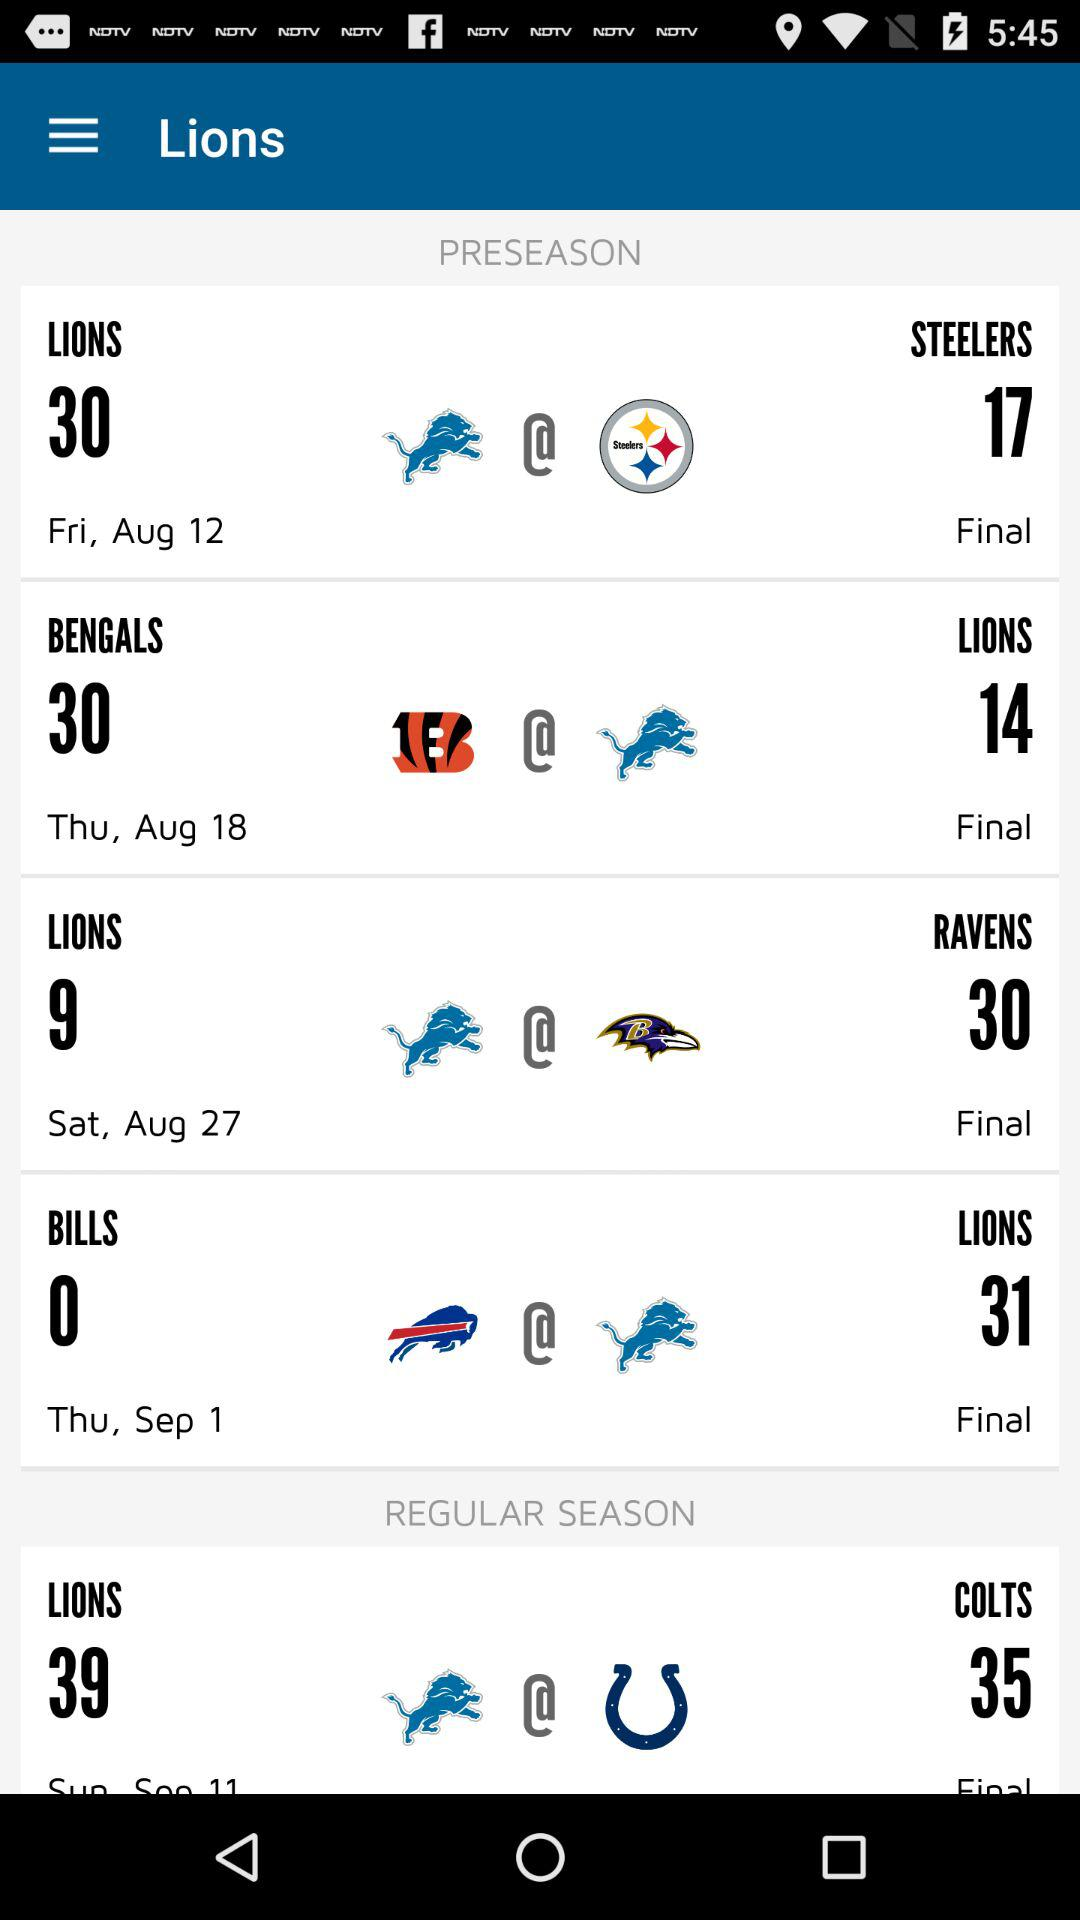How many more preseason games are there than regular season games?
Answer the question using a single word or phrase. 3 